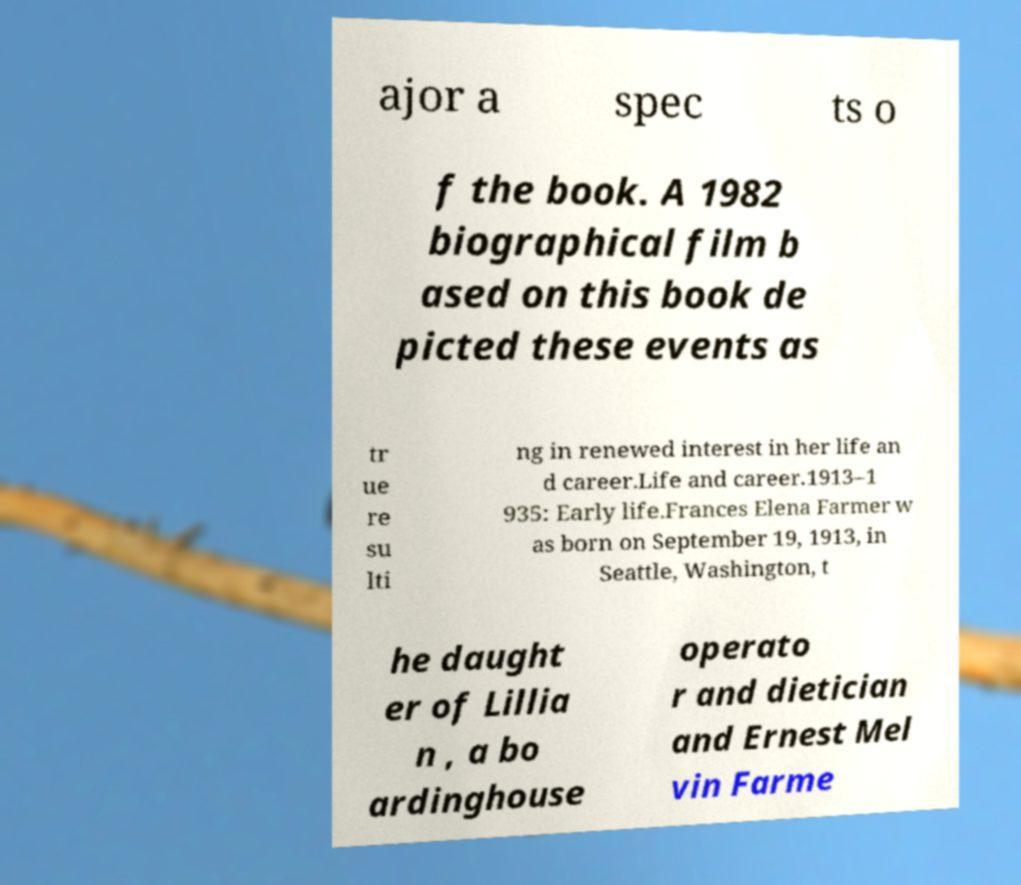Please identify and transcribe the text found in this image. ajor a spec ts o f the book. A 1982 biographical film b ased on this book de picted these events as tr ue re su lti ng in renewed interest in her life an d career.Life and career.1913–1 935: Early life.Frances Elena Farmer w as born on September 19, 1913, in Seattle, Washington, t he daught er of Lillia n , a bo ardinghouse operato r and dietician and Ernest Mel vin Farme 